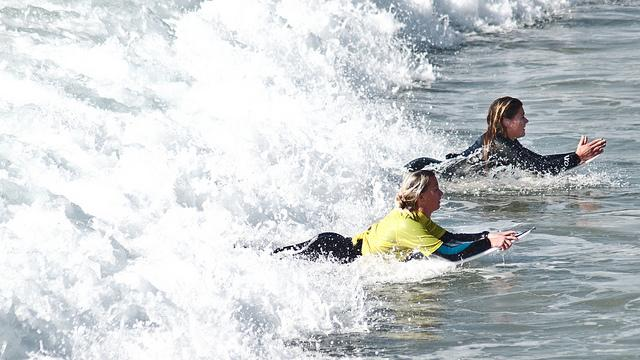What should one be good at before one begins to learn this sport? swimming 